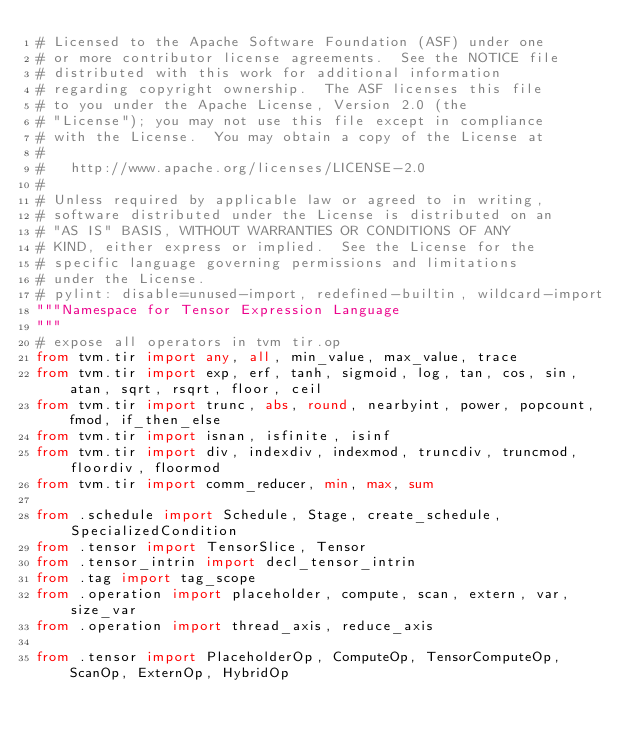<code> <loc_0><loc_0><loc_500><loc_500><_Python_># Licensed to the Apache Software Foundation (ASF) under one
# or more contributor license agreements.  See the NOTICE file
# distributed with this work for additional information
# regarding copyright ownership.  The ASF licenses this file
# to you under the Apache License, Version 2.0 (the
# "License"); you may not use this file except in compliance
# with the License.  You may obtain a copy of the License at
#
#   http://www.apache.org/licenses/LICENSE-2.0
#
# Unless required by applicable law or agreed to in writing,
# software distributed under the License is distributed on an
# "AS IS" BASIS, WITHOUT WARRANTIES OR CONDITIONS OF ANY
# KIND, either express or implied.  See the License for the
# specific language governing permissions and limitations
# under the License.
# pylint: disable=unused-import, redefined-builtin, wildcard-import
"""Namespace for Tensor Expression Language
"""
# expose all operators in tvm tir.op
from tvm.tir import any, all, min_value, max_value, trace
from tvm.tir import exp, erf, tanh, sigmoid, log, tan, cos, sin, atan, sqrt, rsqrt, floor, ceil
from tvm.tir import trunc, abs, round, nearbyint, power, popcount, fmod, if_then_else
from tvm.tir import isnan, isfinite, isinf
from tvm.tir import div, indexdiv, indexmod, truncdiv, truncmod, floordiv, floormod
from tvm.tir import comm_reducer, min, max, sum

from .schedule import Schedule, Stage, create_schedule, SpecializedCondition
from .tensor import TensorSlice, Tensor
from .tensor_intrin import decl_tensor_intrin
from .tag import tag_scope
from .operation import placeholder, compute, scan, extern, var, size_var
from .operation import thread_axis, reduce_axis

from .tensor import PlaceholderOp, ComputeOp, TensorComputeOp, ScanOp, ExternOp, HybridOp
</code> 